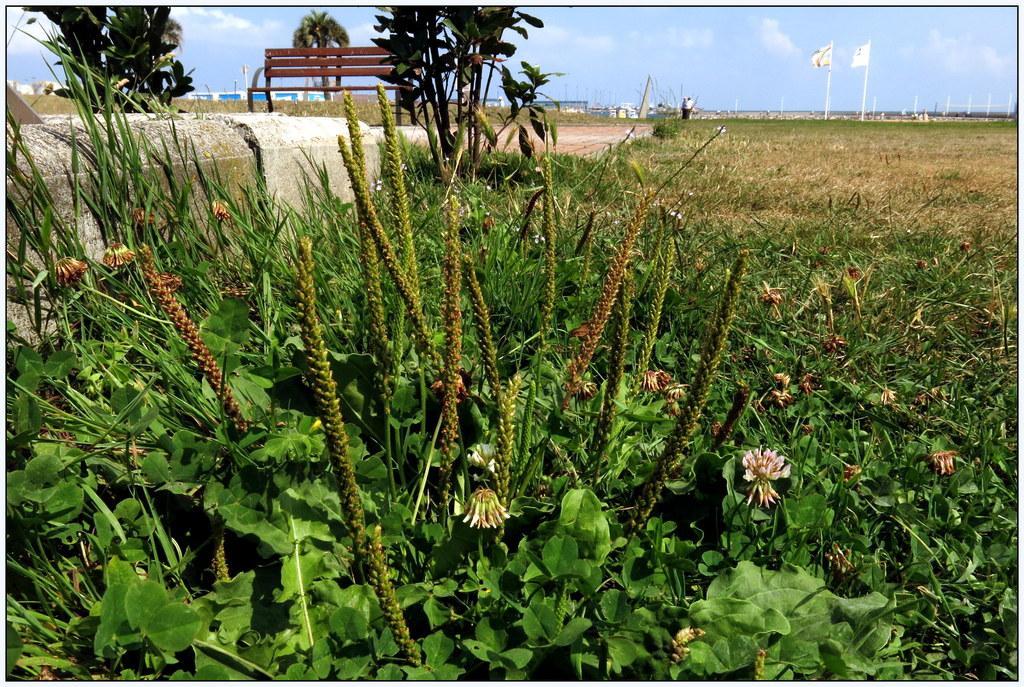Please provide a concise description of this image. In the picture we can see grass plants and behind it, we can see a path and on it we can see a bench and behind it also we can see grass surface and far away from it, we can see a pole, houses and to the right hand side we can see two flags, and some persons standing near to it and in the background we can see a sky with clouds. 